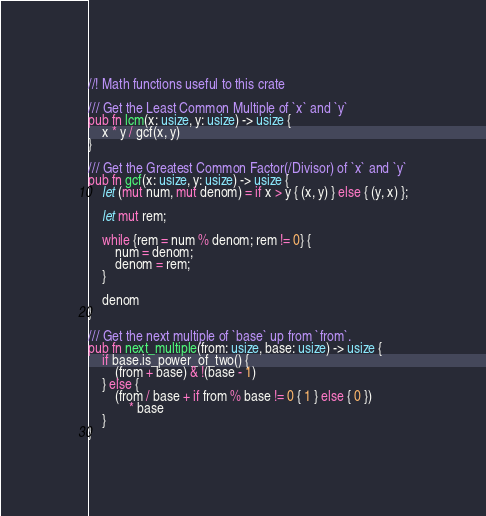<code> <loc_0><loc_0><loc_500><loc_500><_Rust_>//! Math functions useful to this crate

/// Get the Least Common Multiple of `x` and `y`
pub fn lcm(x: usize, y: usize) -> usize {
    x * y / gcf(x, y)
}

/// Get the Greatest Common Factor(/Divisor) of `x` and `y`
pub fn gcf(x: usize, y: usize) -> usize {
    let (mut num, mut denom) = if x > y { (x, y) } else { (y, x) };

    let mut rem;

    while {rem = num % denom; rem != 0} {
        num = denom;
        denom = rem;
    }

    denom
}

/// Get the next multiple of `base` up from `from`.
pub fn next_multiple(from: usize, base: usize) -> usize {
    if base.is_power_of_two() {
        (from + base) & !(base - 1)
    } else {   
        (from / base + if from % base != 0 { 1 } else { 0 })
            * base
    }
} 
</code> 